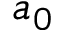<formula> <loc_0><loc_0><loc_500><loc_500>a _ { 0 }</formula> 